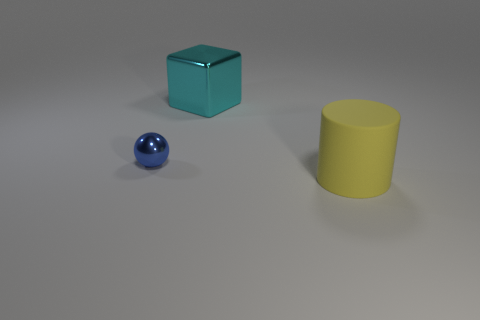There is a thing that is to the left of the object that is behind the tiny metal object; how big is it?
Offer a terse response. Small. What number of yellow rubber cylinders are there?
Ensure brevity in your answer.  1. The metal object that is behind the thing to the left of the big thing to the left of the big matte cylinder is what color?
Provide a succinct answer. Cyan. Is the number of large cylinders less than the number of tiny red rubber cylinders?
Make the answer very short. No. What is the color of the tiny sphere that is the same material as the cyan object?
Offer a very short reply. Blue. How many yellow objects have the same size as the cyan metallic object?
Keep it short and to the point. 1. What material is the small thing?
Keep it short and to the point. Metal. Are there more small brown metal spheres than yellow rubber cylinders?
Provide a short and direct response. No. Do the cyan shiny thing and the large yellow object have the same shape?
Keep it short and to the point. No. Are there any other things that have the same shape as the large cyan metallic object?
Your response must be concise. No. 